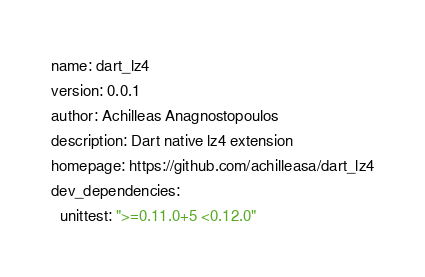Convert code to text. <code><loc_0><loc_0><loc_500><loc_500><_YAML_>name: dart_lz4
version: 0.0.1
author: Achilleas Anagnostopoulos
description: Dart native lz4 extension
homepage: https://github.com/achilleasa/dart_lz4
dev_dependencies:
  unittest: ">=0.11.0+5 <0.12.0"
</code> 